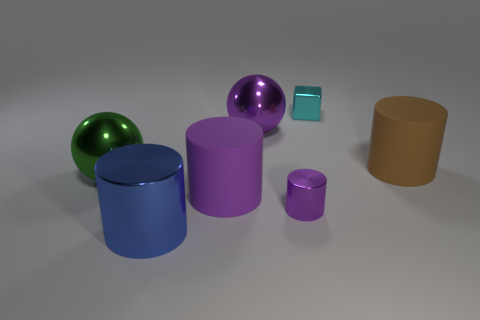Subtract all brown cylinders. How many cylinders are left? 3 Subtract all large cylinders. How many cylinders are left? 1 Add 1 small brown spheres. How many objects exist? 8 Subtract all cylinders. How many objects are left? 3 Subtract 2 cylinders. How many cylinders are left? 2 Subtract all red cylinders. Subtract all blue spheres. How many cylinders are left? 4 Subtract all red cylinders. How many gray balls are left? 0 Subtract all small cyan blocks. Subtract all small blue objects. How many objects are left? 6 Add 4 blue cylinders. How many blue cylinders are left? 5 Add 6 gray matte spheres. How many gray matte spheres exist? 6 